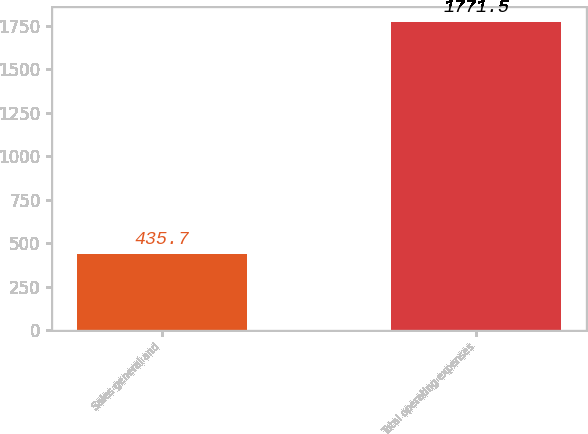<chart> <loc_0><loc_0><loc_500><loc_500><bar_chart><fcel>Sales general and<fcel>Total operating expenses<nl><fcel>435.7<fcel>1771.5<nl></chart> 